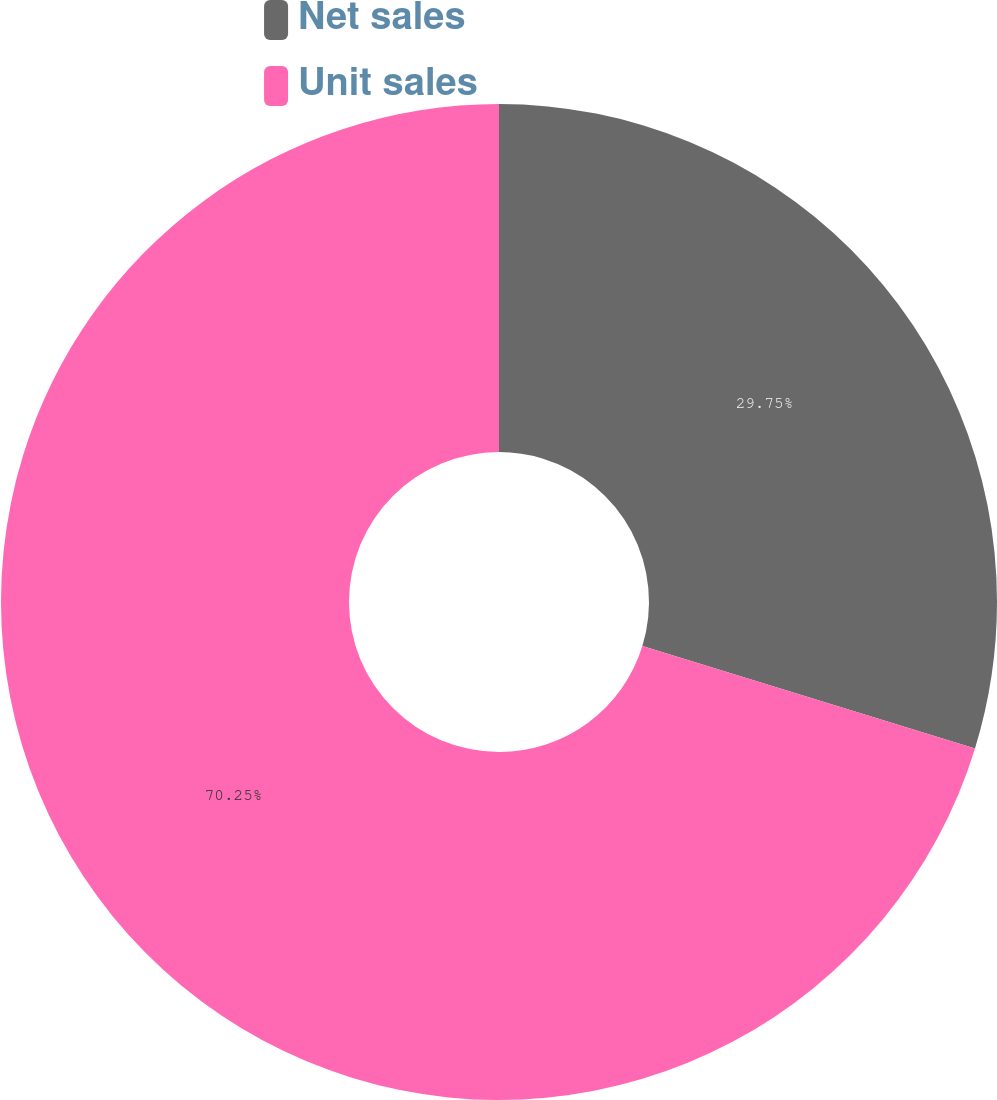Convert chart. <chart><loc_0><loc_0><loc_500><loc_500><pie_chart><fcel>Net sales<fcel>Unit sales<nl><fcel>29.75%<fcel>70.25%<nl></chart> 